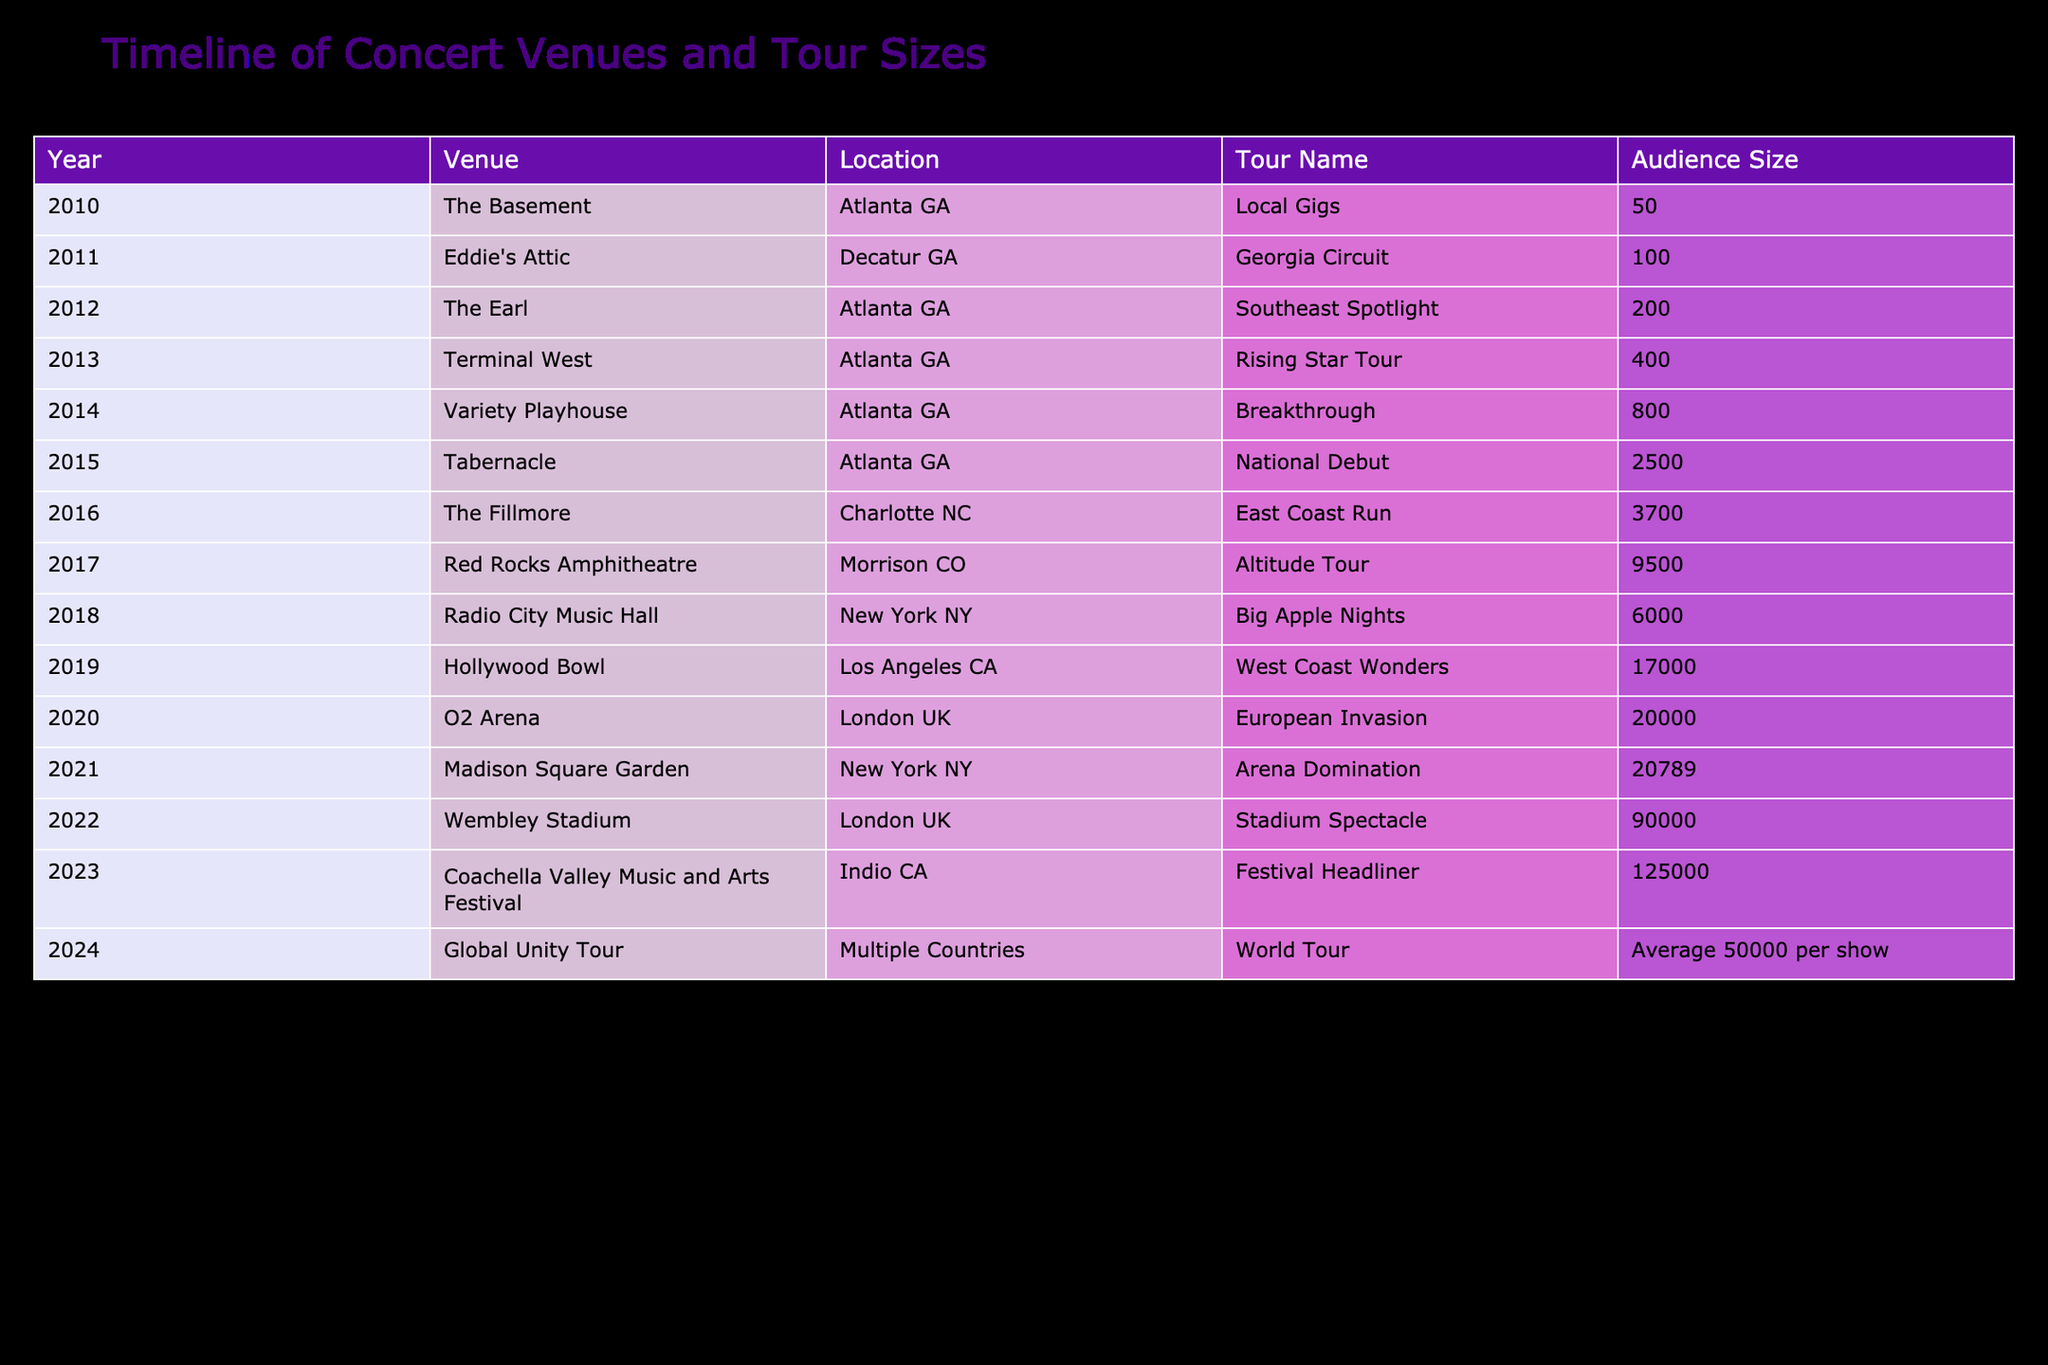What was the largest audience size in a single concert, and in what year did it occur? The largest audience size in a single concert can be found by looking for the highest number in the Audience Size column, which is 125,000 in the year 2023 at the Coachella Valley Music and Arts Festival.
Answer: 125000 in 2023 Which venue hosted the artist's first significant tour and what was the audience size? The artist's first significant tour is the "Georgia Circuit" in 2011 at Eddie's Attic, which had an audience size of 100.
Answer: Eddie's Attic, 100 Did the artist perform in a stadium in 2022? Yes, the artist performed at Wembley Stadium in London, UK, which indicates that it is a stadium venue according to the table.
Answer: Yes What is the total audience size from the first five years listed in the table? To find the total audience size for the first five years (2010-2014), we sum up the audience sizes: 50 (2010) + 100 (2011) + 200 (2012) + 400 (2013) + 800 (2014) = 1550.
Answer: 1550 During which tour did the artist reach an audience size of over 20,000, and in what year? The artist reached an audience size of over 20,000 during the "Arena Domination" tour in 2021, with an audience of 20,789.
Answer: Arena Domination, 2021 Which year marked the transition from local gigs to larger venues, and what was the venue and audience size for that year? The transition from local gigs to larger venues occurred in 2015 with the performance at the Tabernacle, which had an audience size of 2,500.
Answer: 2015, Tabernacle, 2500 How many venues are listed in the table? The total count of venues is obtained by counting the unique venue names listed in the Venue column, which total 15.
Answer: 15 What is the average audience size of the tours from 2013 to 2019? We find the average audience size from 2013 to 2019 by summing the audiences: 400 (2013) + 800 (2014) + 2500 (2015) + 3700 (2016) + 6000 (2017) + 17000 (2018) = 30700. Then, divide by the number of years (6), which gives an average of 5116.67 rounded down to 5116.
Answer: 5116 